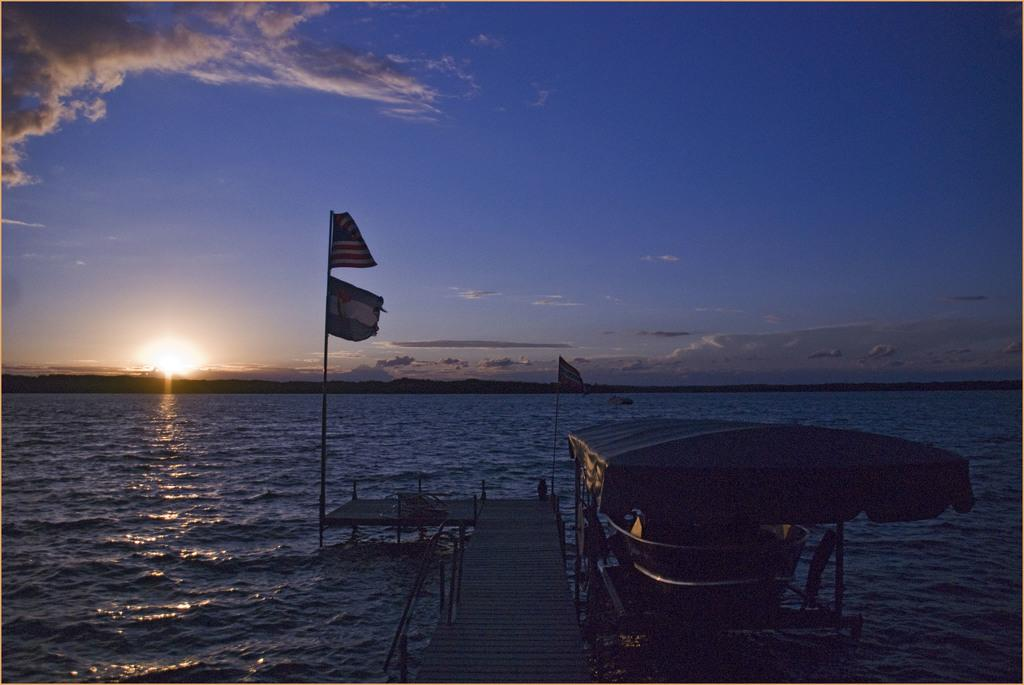What can be seen in the sky in the image? The sky is visible in the image, and there are clouds in the sky. What celestial body is visible in the image? The sun is visible in the image. What type of water is present in the image? There is water in the image, but it is not specified whether it is a river, lake, or ocean. What type of structure is present in the image? There is a walkway bridge in the image. What additional objects can be seen in the image? There are flags and a ship in the image. How many women are visible in the image? There are no women present in the image. What type of pollution can be seen in the image? There is no pollution visible in the image. 